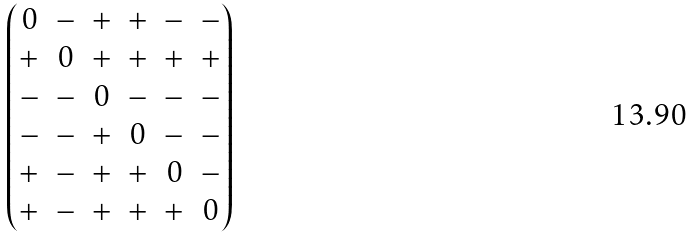<formula> <loc_0><loc_0><loc_500><loc_500>\begin{pmatrix} 0 & - & + & + & - & - \\ + & 0 & + & + & + & + \\ - & - & 0 & - & - & - \\ - & - & + & 0 & - & - \\ + & - & + & + & 0 & - \\ + & - & + & + & + & 0 \end{pmatrix}</formula> 